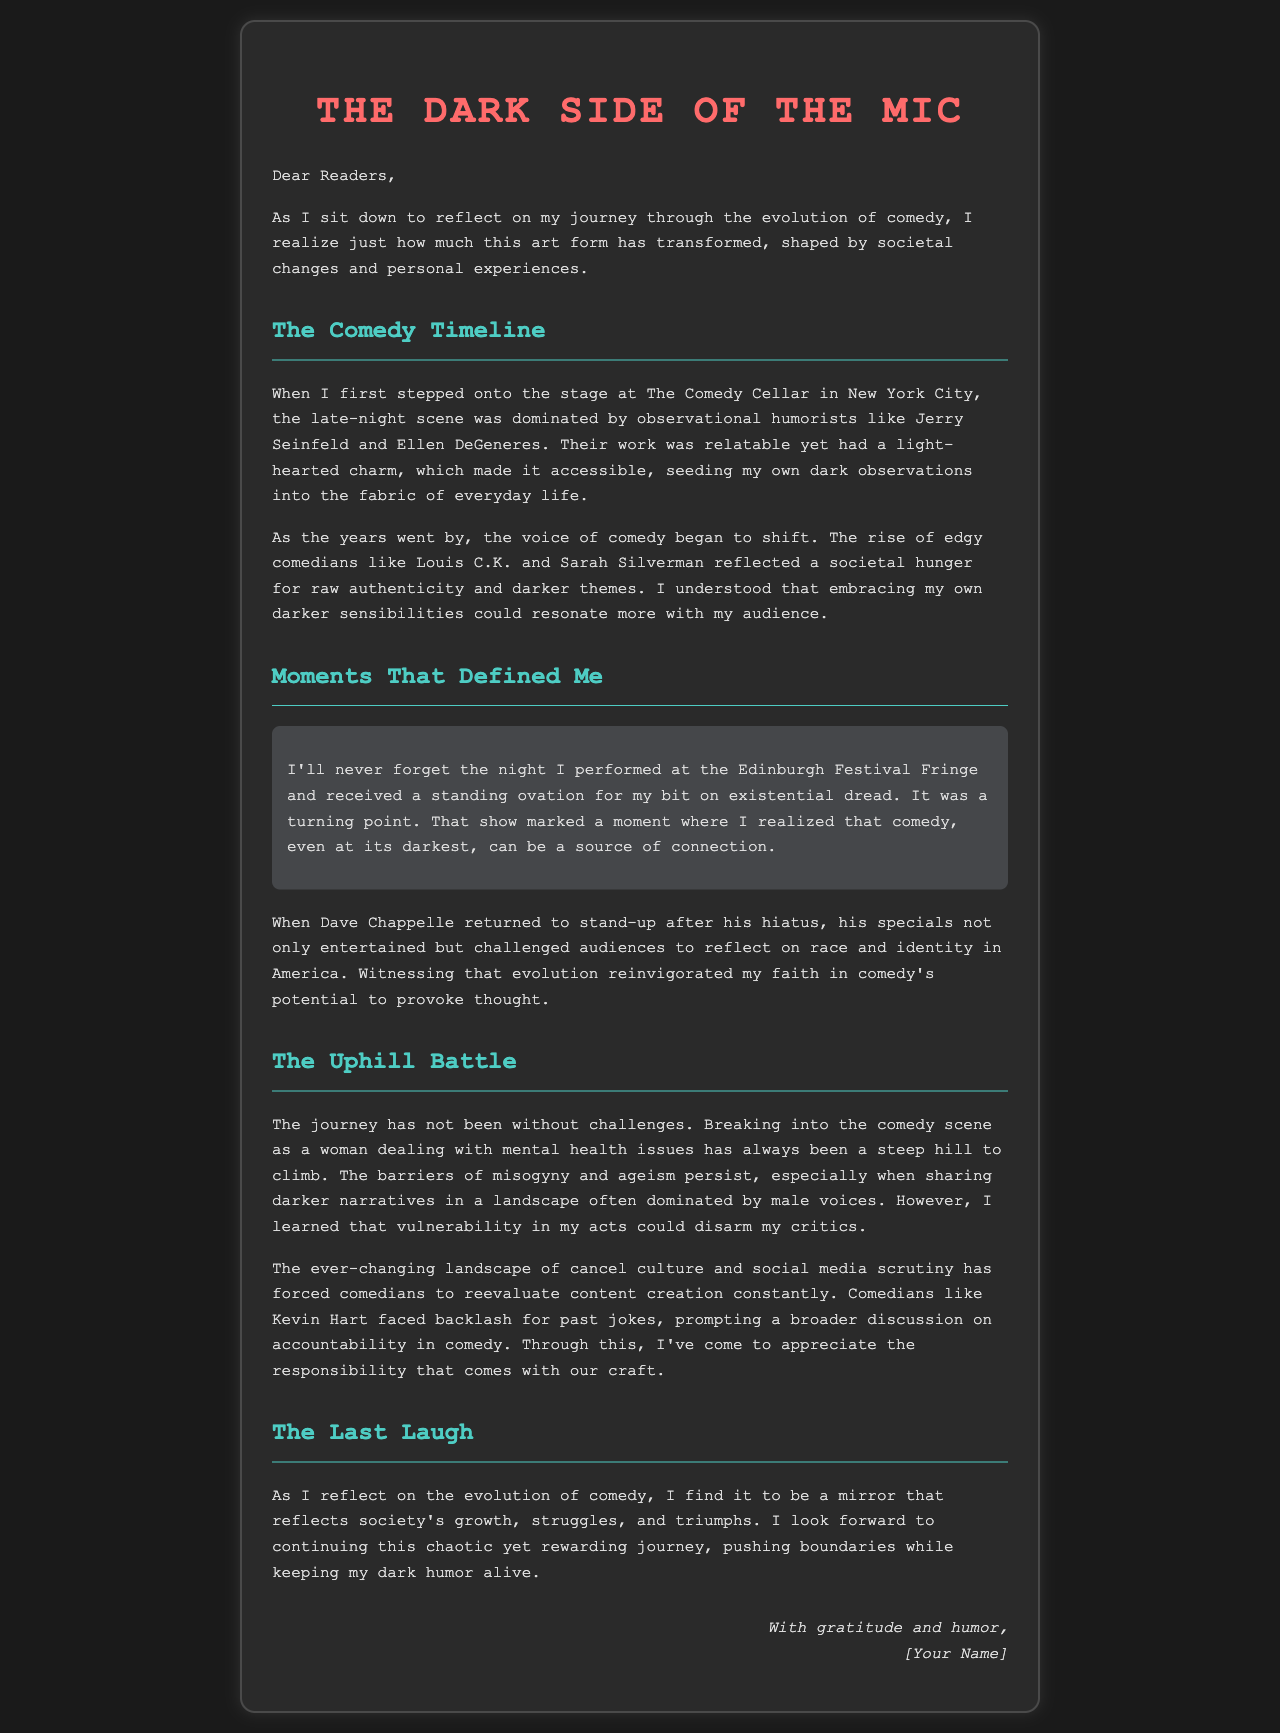What is the title of the letter? The title is prominently displayed at the top of the document, indicating the main theme of the letter.
Answer: The Dark Side of the Mic Who performed at The Comedy Cellar? The text mentions an early experience at The Comedy Cellar, highlighting a key moment in the author's career.
Answer: Jerry Seinfeld What is highlighted in the moment that defined the author? The highlighted section focuses on a memorable performance that had a significant impact on the author's perspective on comedy.
Answer: Existential dread Which comedian's return to stand-up influenced the author? This comedian's return and special performances had a profound effect on the author's appreciation for the art of comedy.
Answer: Dave Chappelle What challenges did the author face in the comedy scene? The document outlines specific barriers the author encountered while trying to establish her career.
Answer: Misogyny and ageism What societal issue is mentioned regarding the evolution of comedy? The letter discusses how the comedy landscape has evolved in response to broader societal discussions.
Answer: Cancel culture What is the author's ultimate goal in comedy? The conclusion of the letter expresses the author's aspirations and drive for her future work in comedy.
Answer: Push boundaries Who is the signature attributed to? The signature provides a personal touch to the letter, indicating authorship.
Answer: [Your Name] 